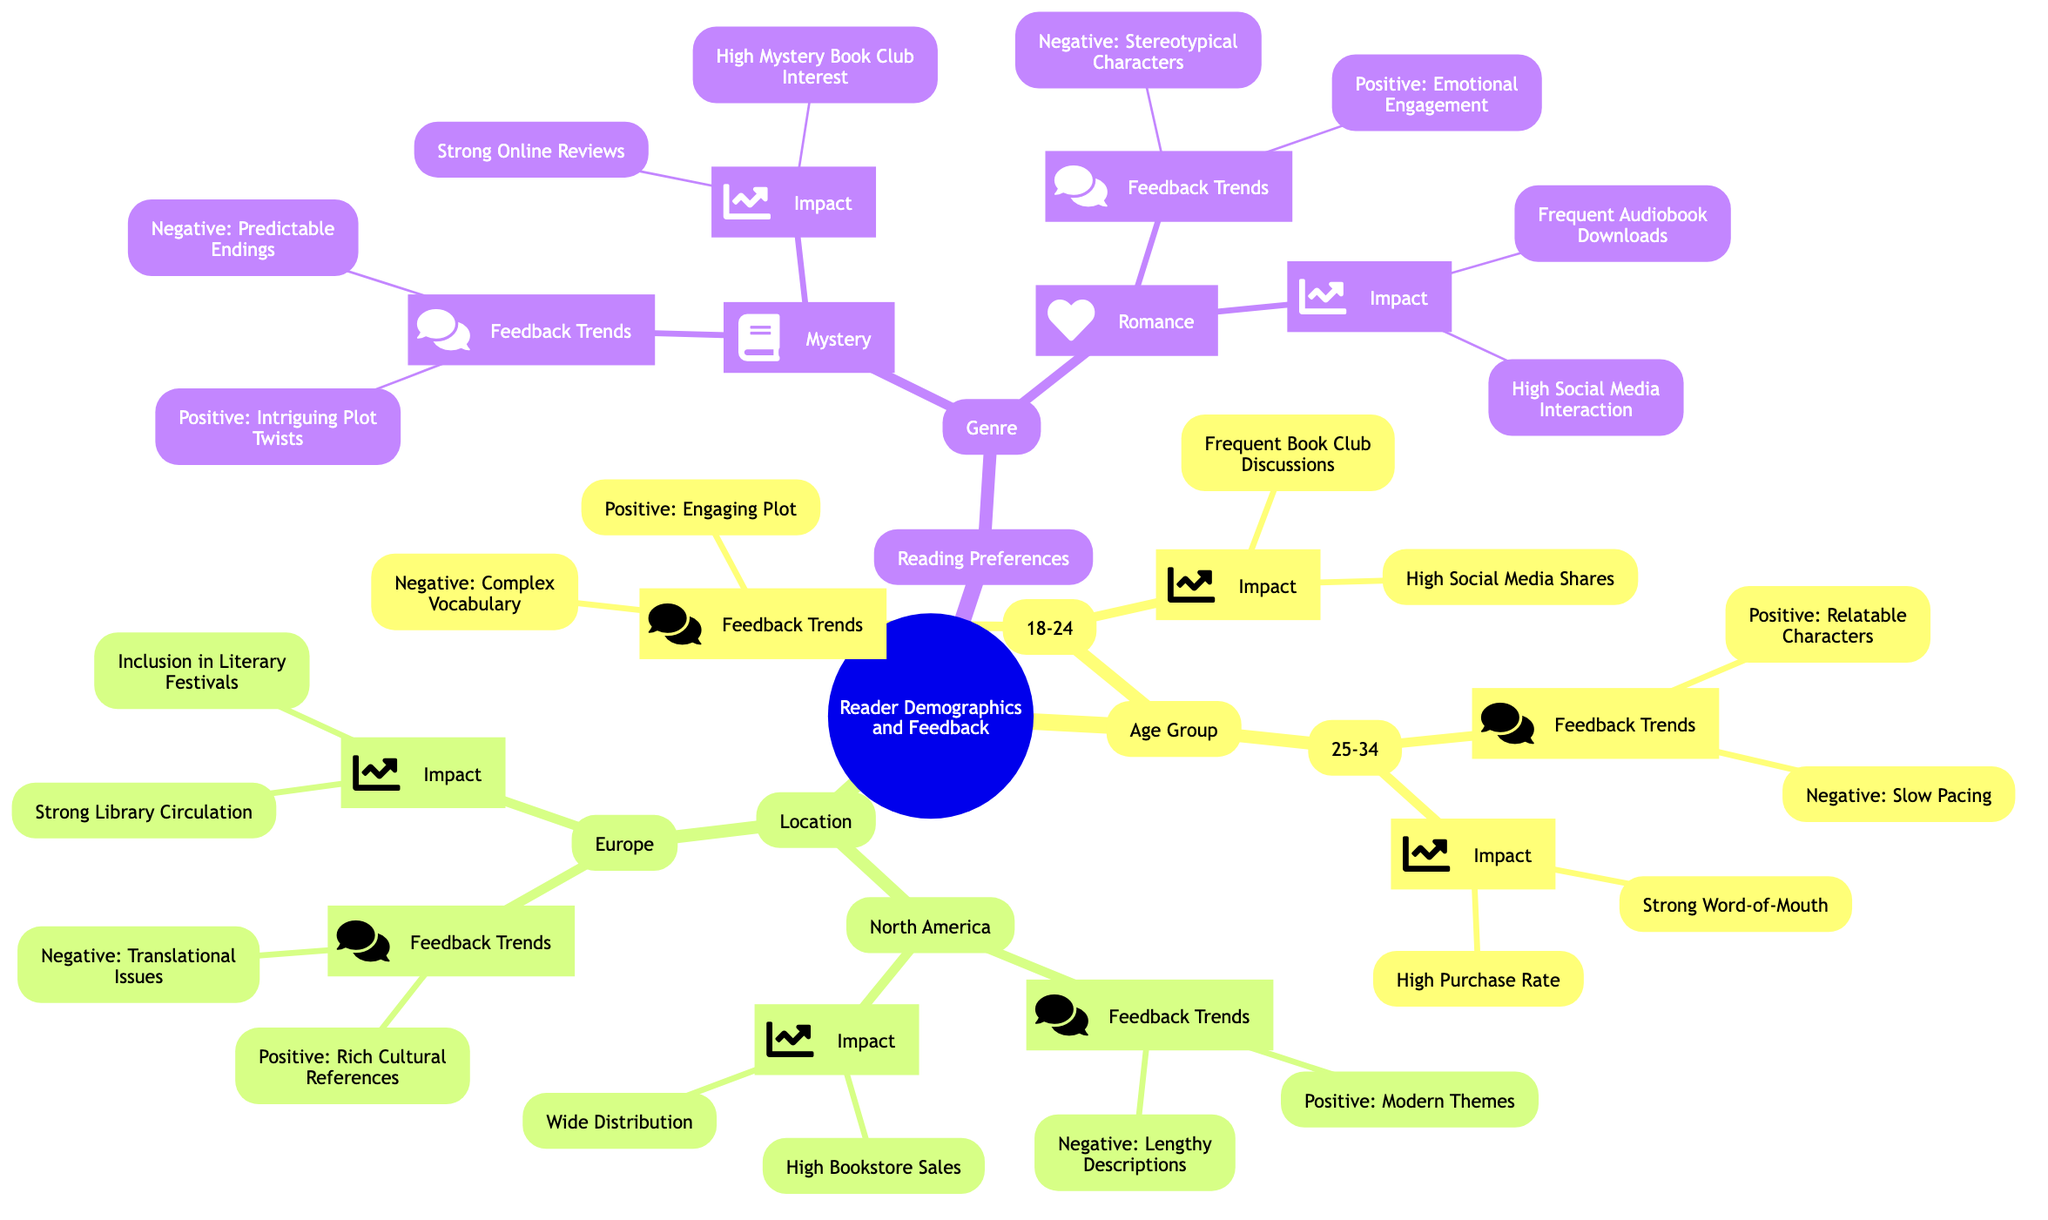What is the feedback trend for the 18-24 age group? The feedback trend lists two aspects. The positive trend is "Engaging Plot" and the negative trend is "Complex Vocabulary".
Answer: Engaging Plot, Complex Vocabulary How many demographic groups are represented in the diagram? The diagram contains three main demographic groups: Age Group, Location, and Reading Preferences.
Answer: 3 What is the impact of the North America demographic? The impact for this demographic shows two aspects: "High Bookstore Sales" and "Wide Distribution".
Answer: High Bookstore Sales, Wide Distribution Which age group has a positive feedback trend related to 'Relatable Characters'? The age group listed under feedback for 'Relatable Characters' is 25-34.
Answer: 25-34 What are the negative feedback trends for the Romance genre? The negative feedback trend for Romance is "Stereotypical Characters".
Answer: Stereotypical Characters Which age group is associated with 'High Social Media Shares'? The age group associated with 'High Social Media Shares' is 18-24.
Answer: 18-24 What feedback trends are shared by the European demographic? The European demographic has a positive trend of "Rich Cultural References" and a negative trend "Translational Issues".
Answer: Rich Cultural References, Translational Issues Which reading preference genre has feedback about 'Predictable Endings'? The genre with feedback about 'Predictable Endings' is Mystery.
Answer: Mystery Which demographic group reports a strong impact of 'Strong Library Circulation'? The demographic group reporting this impact is Europe.
Answer: Europe 